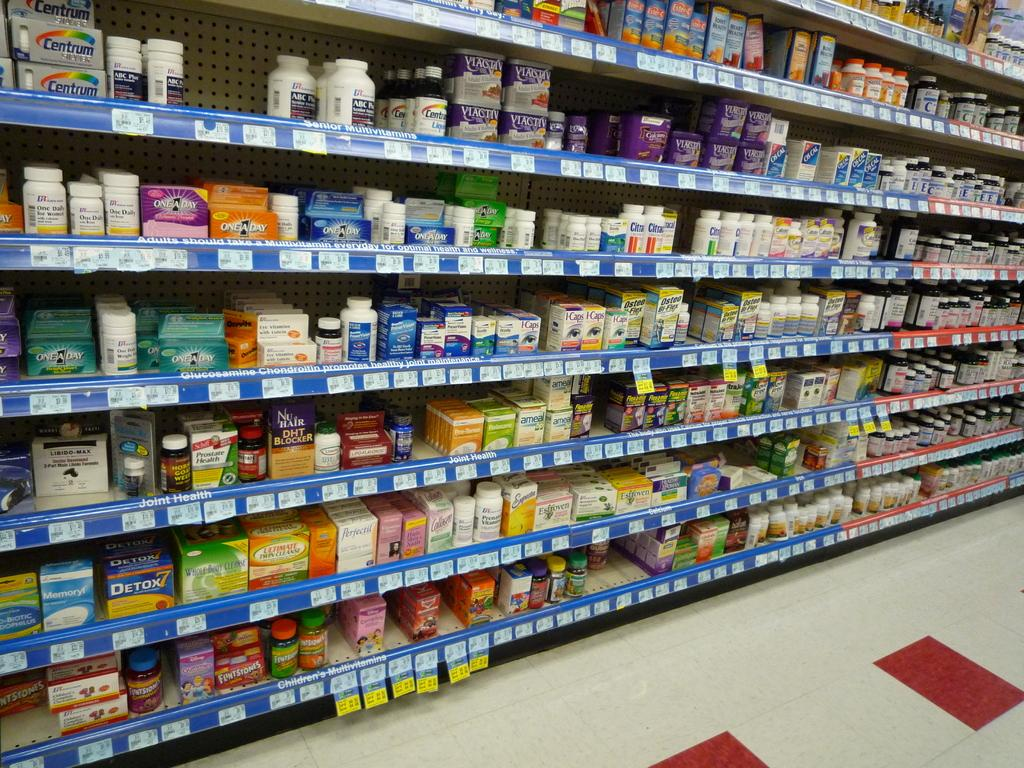What type of items are visible in the image? There are medical products in the image. Where are the medical products located? The medical products are on a rack shelf. What type of machine is used for playing at the playground in the image? There is no machine or playground present in the image; it only features medical products on a rack shelf. 